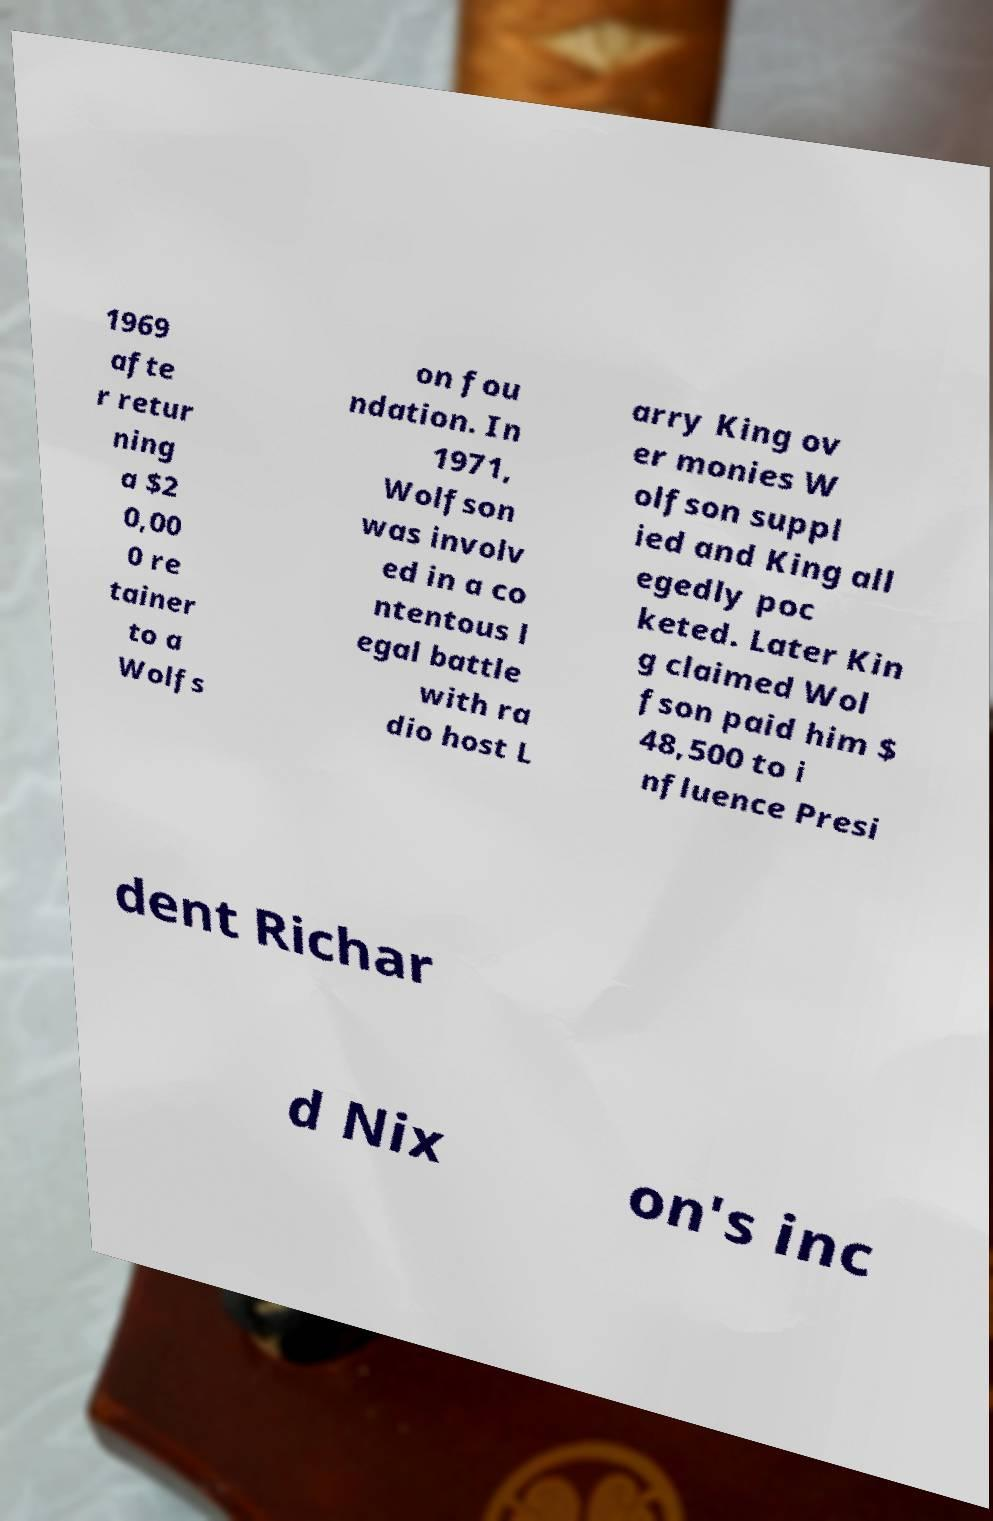Can you read and provide the text displayed in the image?This photo seems to have some interesting text. Can you extract and type it out for me? 1969 afte r retur ning a $2 0,00 0 re tainer to a Wolfs on fou ndation. In 1971, Wolfson was involv ed in a co ntentous l egal battle with ra dio host L arry King ov er monies W olfson suppl ied and King all egedly poc keted. Later Kin g claimed Wol fson paid him $ 48,500 to i nfluence Presi dent Richar d Nix on's inc 